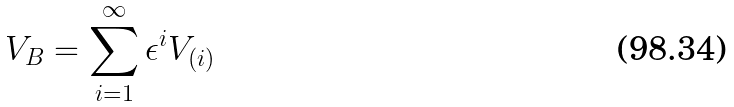<formula> <loc_0><loc_0><loc_500><loc_500>V _ { B } = \sum _ { i = 1 } ^ { \infty } \epsilon ^ { i } V _ { ( i ) }</formula> 